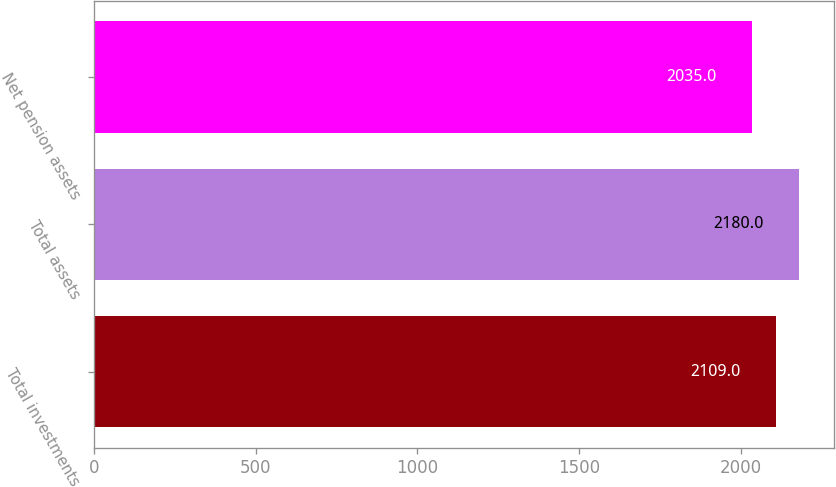<chart> <loc_0><loc_0><loc_500><loc_500><bar_chart><fcel>Total investments<fcel>Total assets<fcel>Net pension assets<nl><fcel>2109<fcel>2180<fcel>2035<nl></chart> 